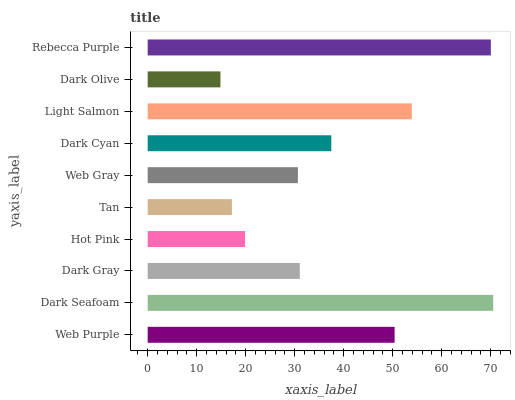Is Dark Olive the minimum?
Answer yes or no. Yes. Is Dark Seafoam the maximum?
Answer yes or no. Yes. Is Dark Gray the minimum?
Answer yes or no. No. Is Dark Gray the maximum?
Answer yes or no. No. Is Dark Seafoam greater than Dark Gray?
Answer yes or no. Yes. Is Dark Gray less than Dark Seafoam?
Answer yes or no. Yes. Is Dark Gray greater than Dark Seafoam?
Answer yes or no. No. Is Dark Seafoam less than Dark Gray?
Answer yes or no. No. Is Dark Cyan the high median?
Answer yes or no. Yes. Is Dark Gray the low median?
Answer yes or no. Yes. Is Light Salmon the high median?
Answer yes or no. No. Is Tan the low median?
Answer yes or no. No. 